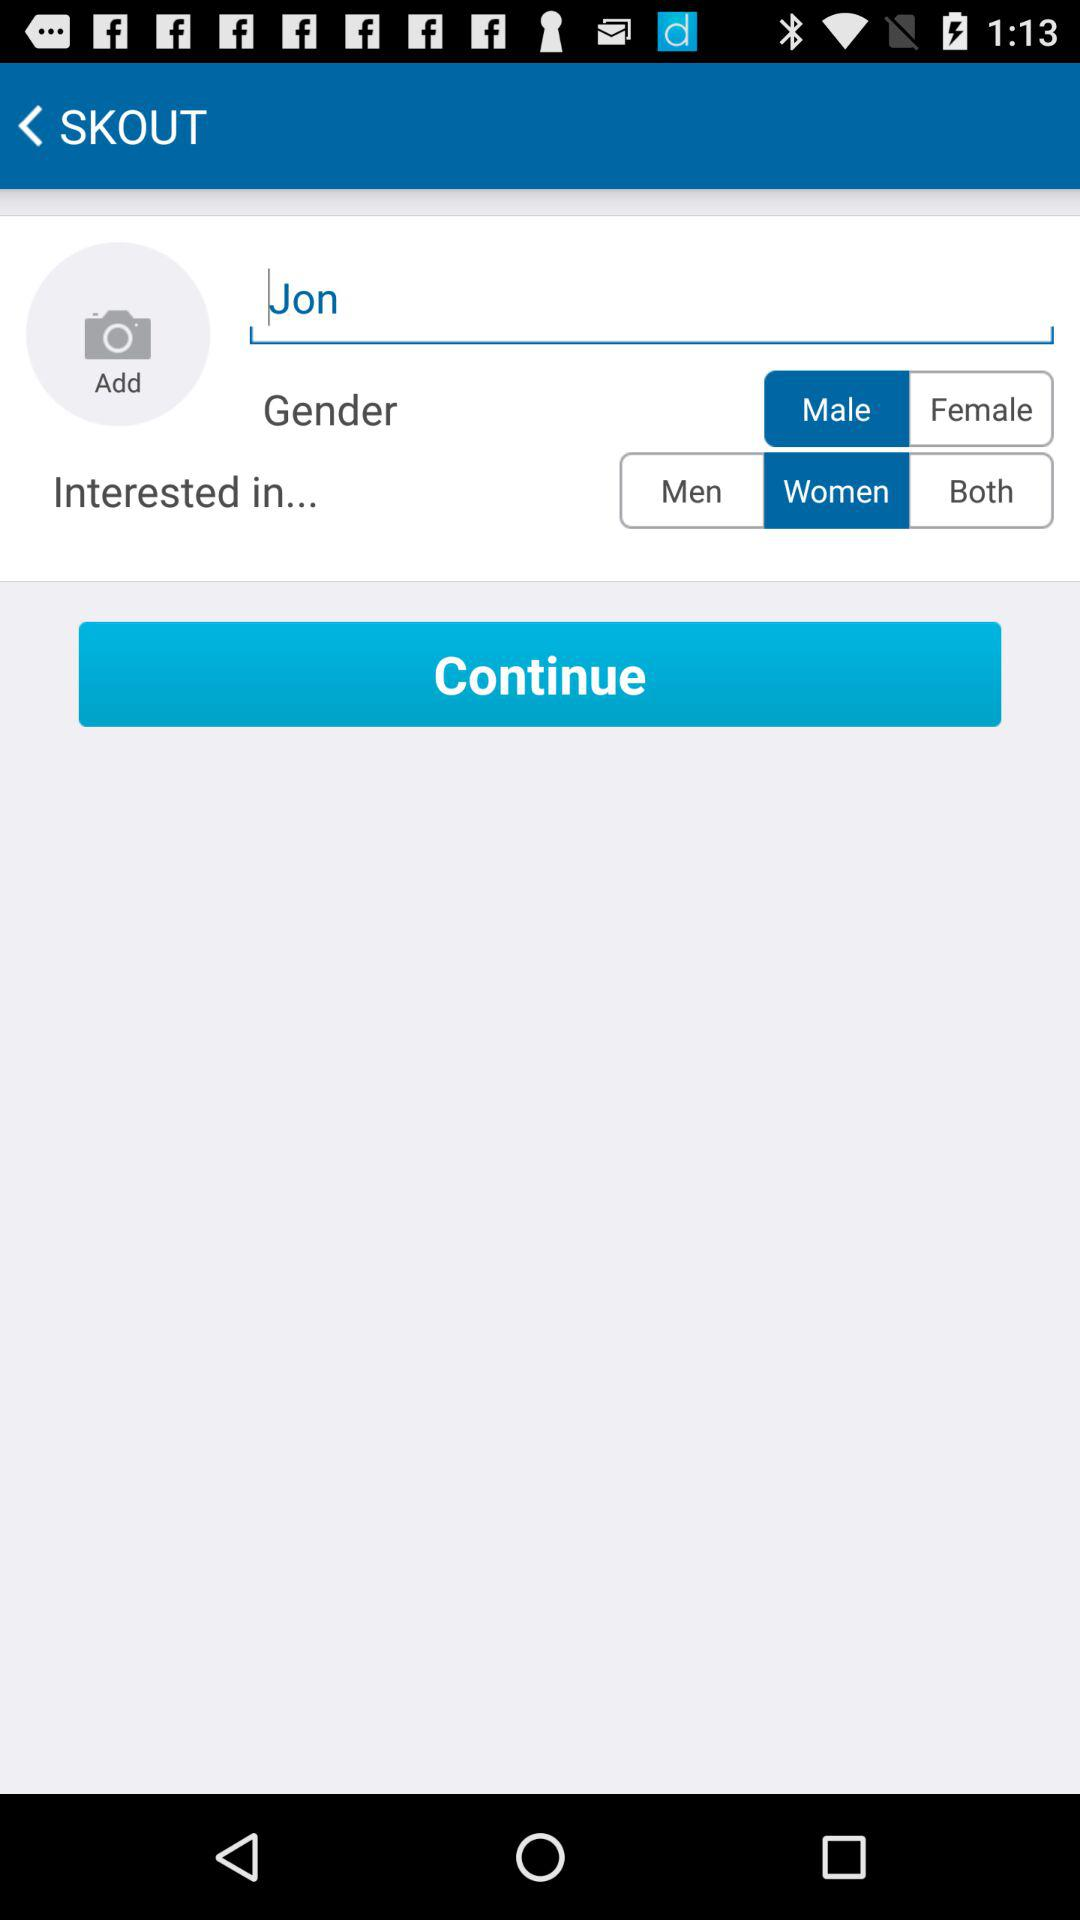What is the mentioned name? The mentioned name is Jon. 